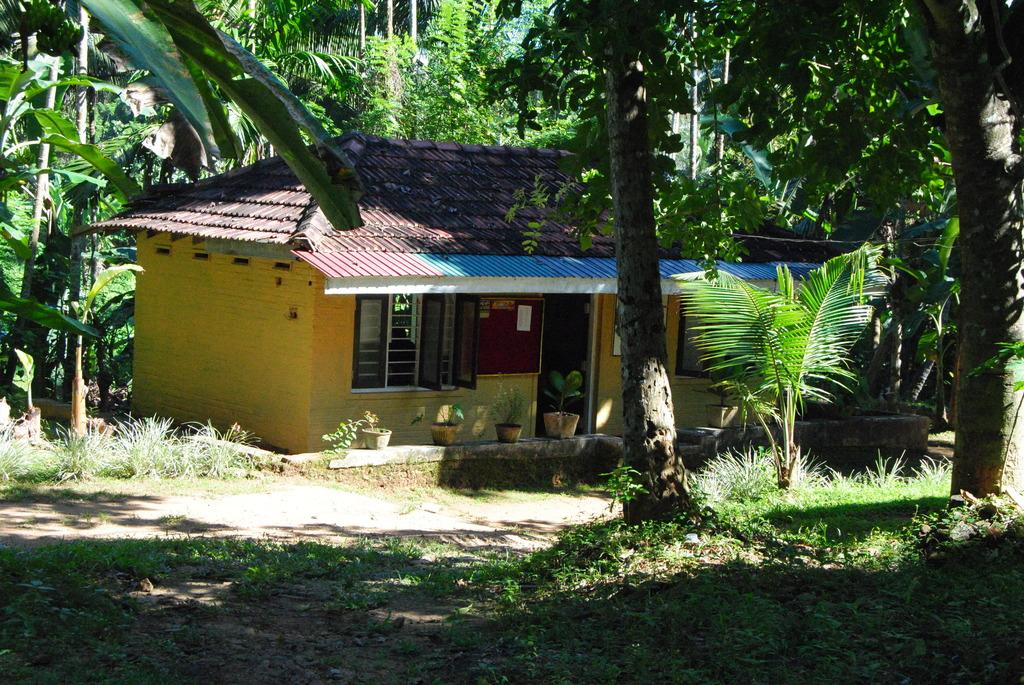What type of structure is present in the image? There is a house in the image. What features can be seen on the house? The house has a door and windows. What is visible beneath the house in the image? There is ground visible in the image. What can be seen in the background of the image? There are trees in the background of the image. What type of vegetation is present at the bottom right of the image? There is green grass at the bottom right of the image. Can you see any worms crawling on the door of the house in the image? There are no worms visible on the door of the house in the image. Is there a zoo located near the house in the image? There is no mention of a zoo in the image or its surroundings. 